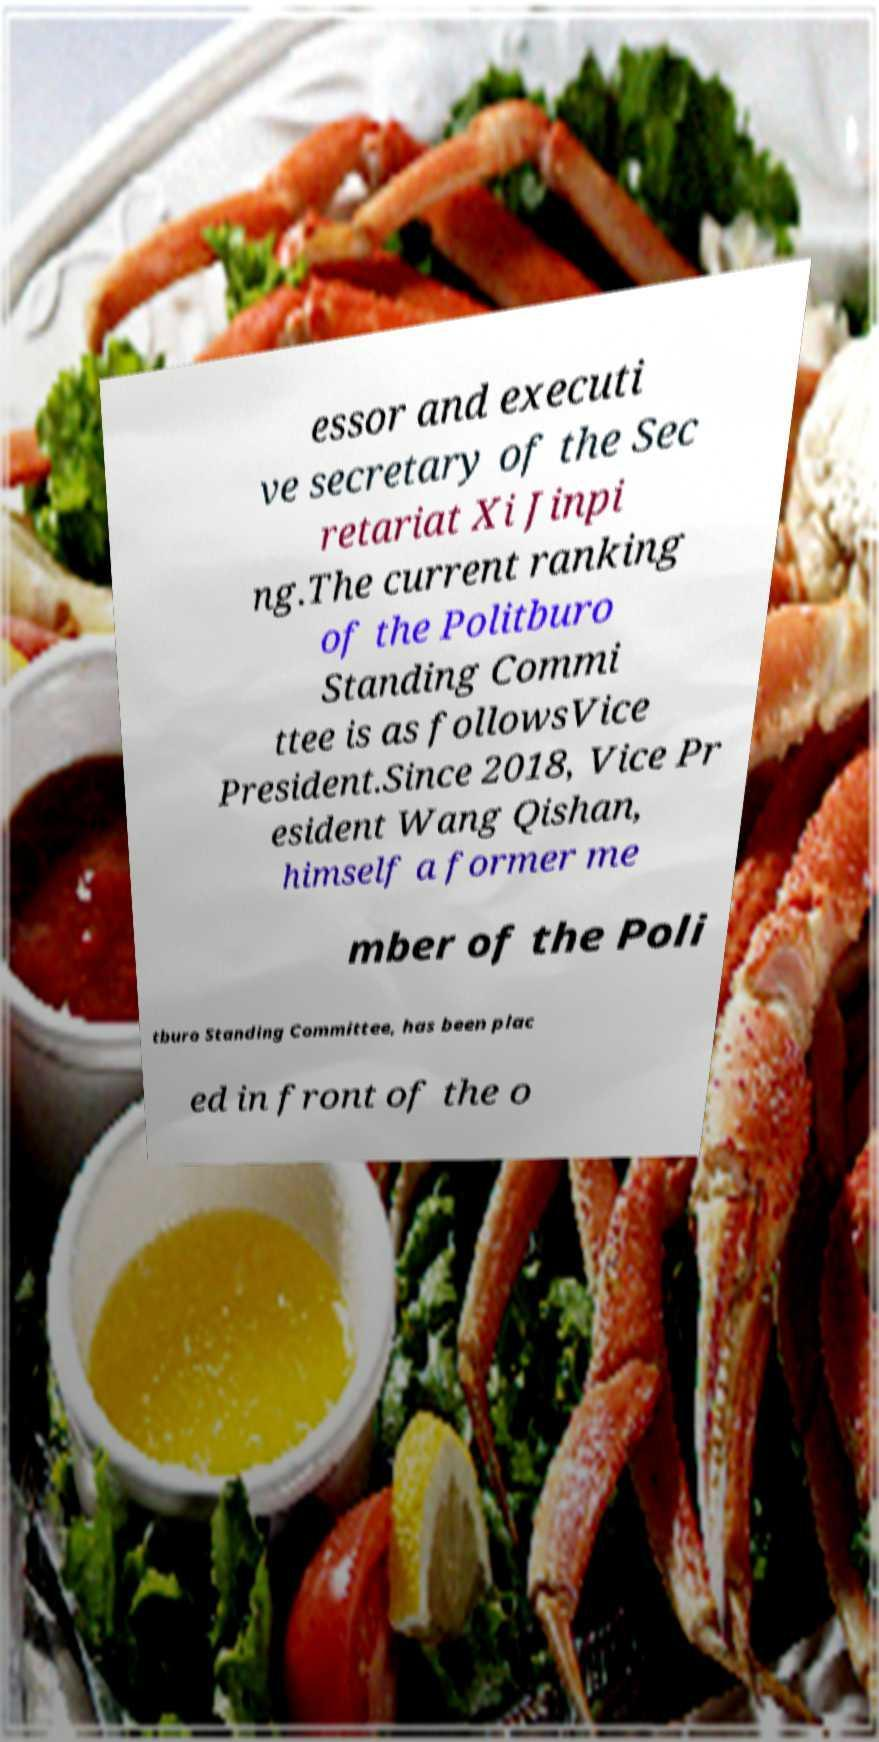Please read and relay the text visible in this image. What does it say? essor and executi ve secretary of the Sec retariat Xi Jinpi ng.The current ranking of the Politburo Standing Commi ttee is as followsVice President.Since 2018, Vice Pr esident Wang Qishan, himself a former me mber of the Poli tburo Standing Committee, has been plac ed in front of the o 